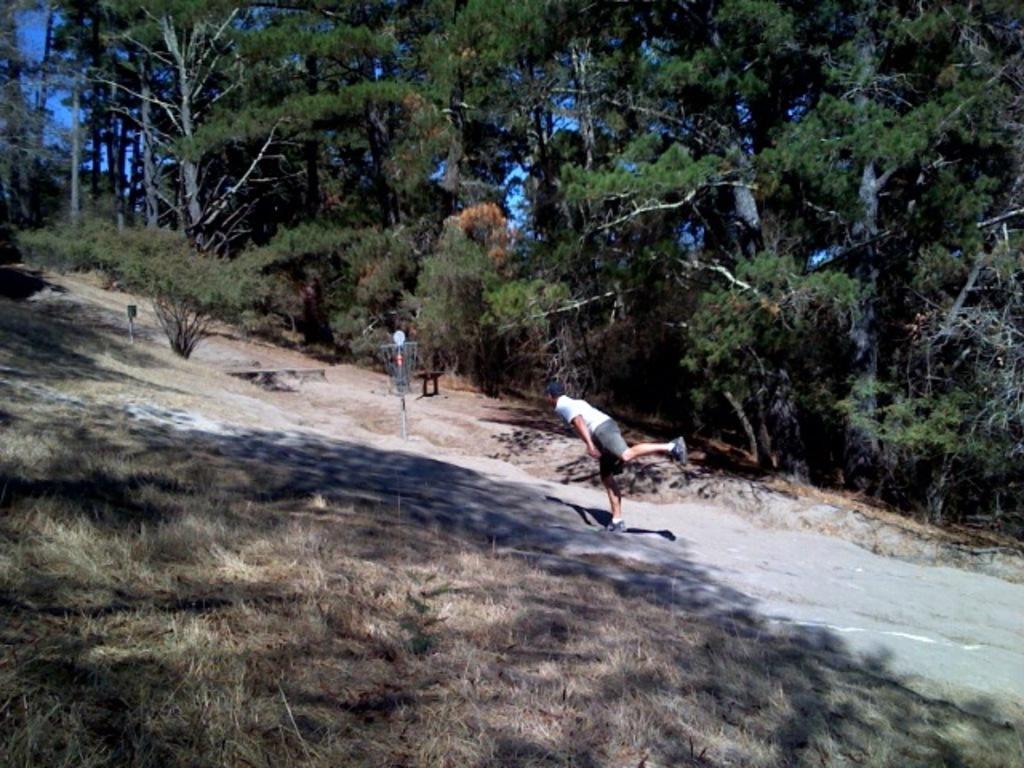How would you summarize this image in a sentence or two? In this image we can see a person. There are few objects on the ground. There is a blue sky in the image. There are many trees and plants in the image. 